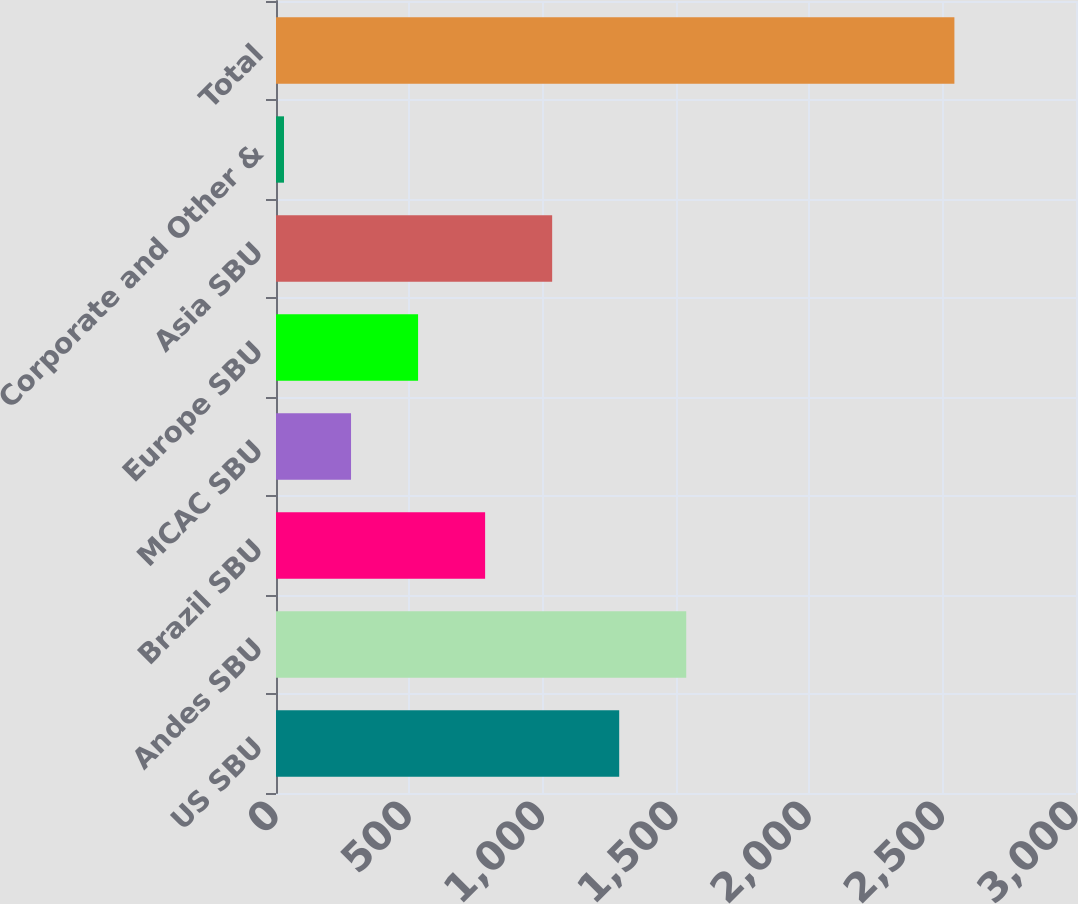<chart> <loc_0><loc_0><loc_500><loc_500><bar_chart><fcel>US SBU<fcel>Andes SBU<fcel>Brazil SBU<fcel>MCAC SBU<fcel>Europe SBU<fcel>Asia SBU<fcel>Corporate and Other &<fcel>Total<nl><fcel>1287<fcel>1538.4<fcel>784.2<fcel>281.4<fcel>532.8<fcel>1035.6<fcel>30<fcel>2544<nl></chart> 